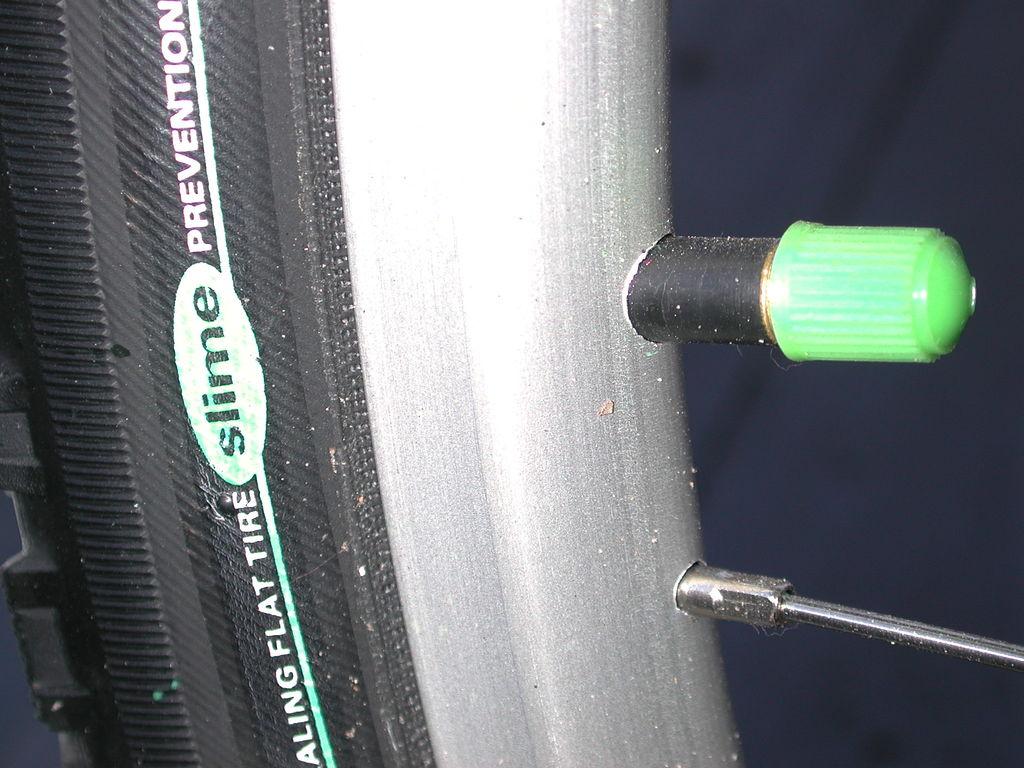What brand of bike tire is this?
Offer a very short reply. Slime. What is the word after the word in green?
Ensure brevity in your answer.  Prevention. 